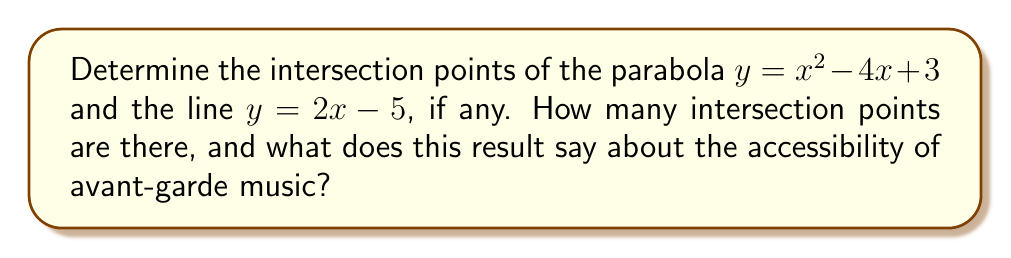Give your solution to this math problem. Let's approach this step-by-step:

1) To find the intersection points, we need to set the equations equal to each other:
   $x^2 - 4x + 3 = 2x - 5$

2) Rearrange the equation to standard form:
   $x^2 - 6x + 8 = 0$

3) This is a quadratic equation. We can solve it using the quadratic formula:
   $x = \frac{-b \pm \sqrt{b^2 - 4ac}}{2a}$

   Where $a = 1$, $b = -6$, and $c = 8$

4) Substituting these values:
   $x = \frac{6 \pm \sqrt{36 - 32}}{2} = \frac{6 \pm \sqrt{4}}{2} = \frac{6 \pm 2}{2}$

5) This gives us two solutions:
   $x_1 = \frac{6 + 2}{2} = 4$ and $x_2 = \frac{6 - 2}{2} = 2$

6) To find the y-coordinates, we can substitute these x-values into either of the original equations. Let's use the line equation:

   For $x_1 = 4$: $y = 2(4) - 5 = 3$
   For $x_2 = 2$: $y = 2(2) - 5 = -1$

Therefore, the intersection points are $(4, 3)$ and $(2, -1)$.

Just as there are two distinct intersection points between this parabola and line, there are typically two distinct groups in music appreciation: those who find avant-garde music accessible and those who don't. The existence of these two points might suggest that avant-garde music, while not universally accessible, does have points of connection with more traditional forms.
Answer: $(4, 3)$ and $(2, -1)$; 2 intersection points 